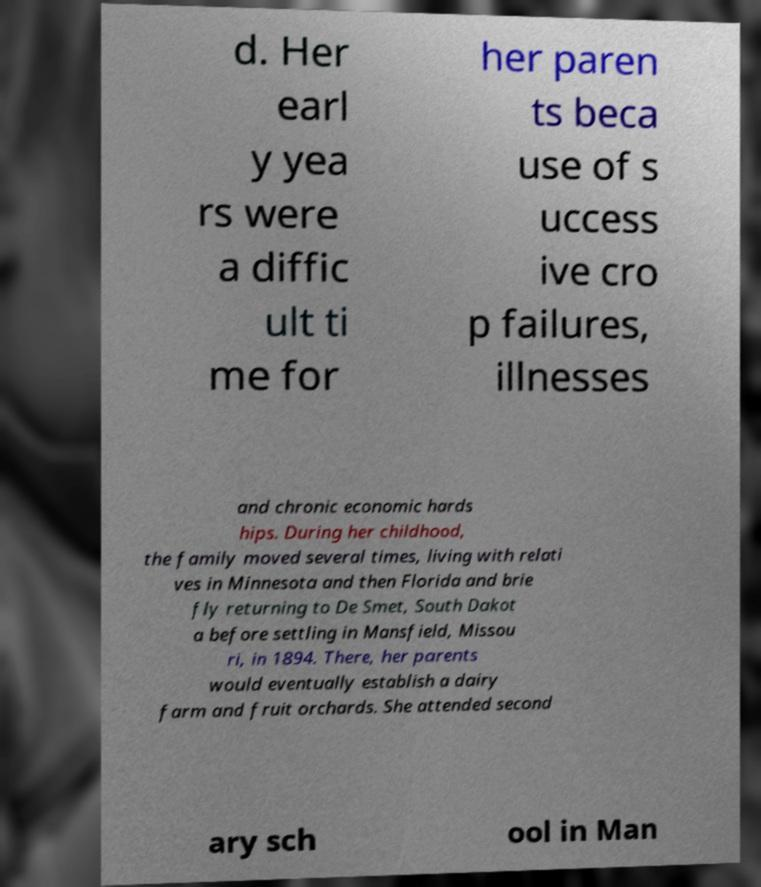For documentation purposes, I need the text within this image transcribed. Could you provide that? d. Her earl y yea rs were a diffic ult ti me for her paren ts beca use of s uccess ive cro p failures, illnesses and chronic economic hards hips. During her childhood, the family moved several times, living with relati ves in Minnesota and then Florida and brie fly returning to De Smet, South Dakot a before settling in Mansfield, Missou ri, in 1894. There, her parents would eventually establish a dairy farm and fruit orchards. She attended second ary sch ool in Man 